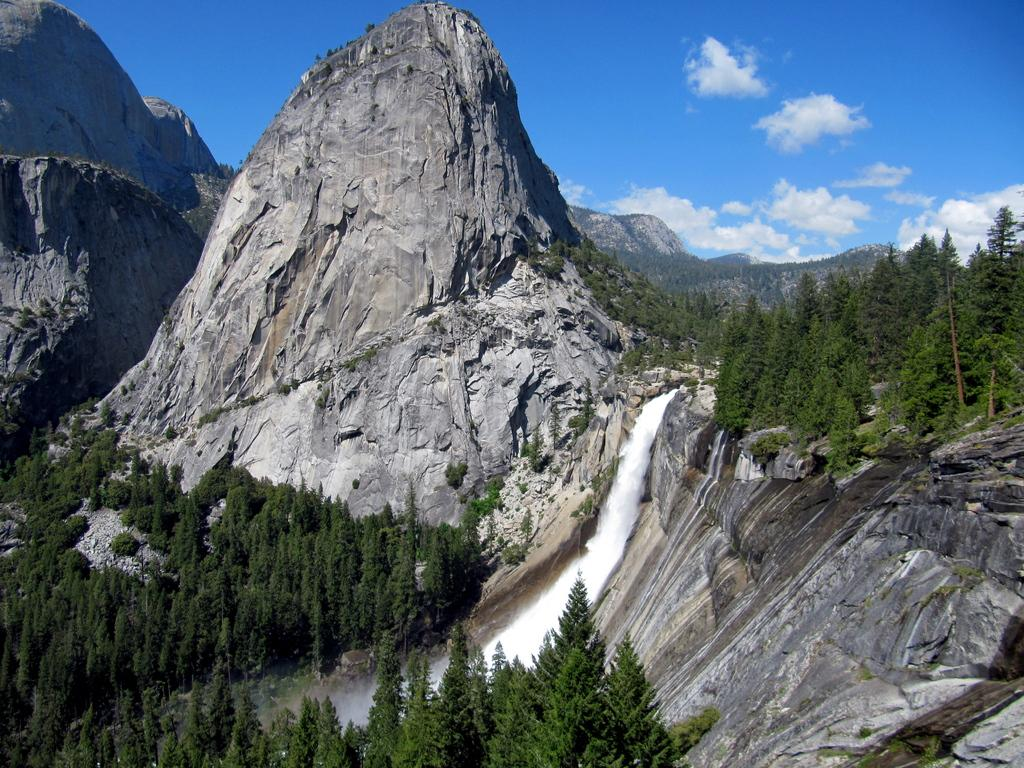What type of natural features can be seen in the image? There are trees, a waterfall, and mountains visible in the image. Where is the waterfall located in the image? The waterfall is in the center of the image. What can be seen in the background of the image? The sky is visible in the background of the image. What type of fruit is hanging from the trees in the image? There is no fruit visible on the trees in the image. What sound can be heard during the recess in the image? There is no indication of a recess or any sounds in the image. 